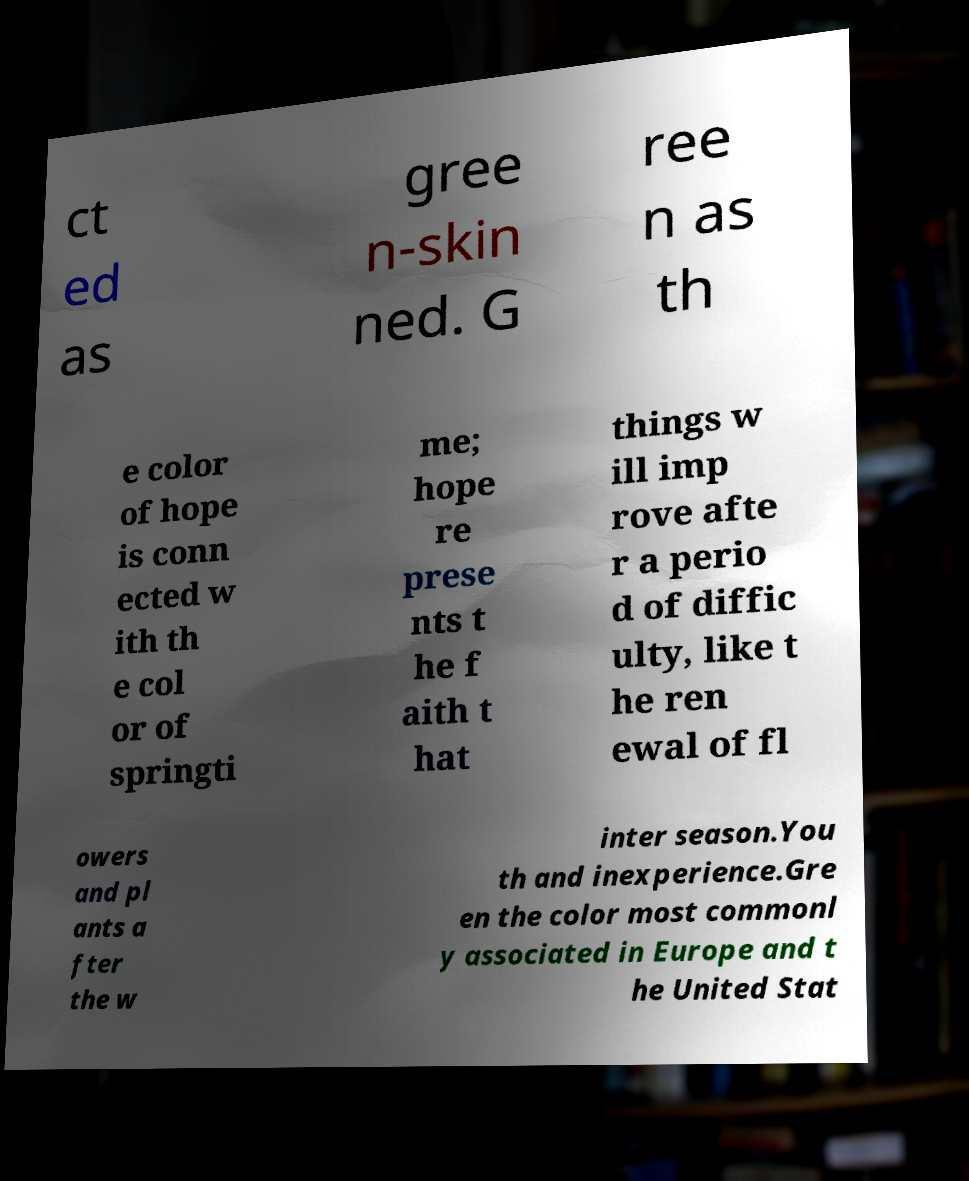For documentation purposes, I need the text within this image transcribed. Could you provide that? ct ed as gree n-skin ned. G ree n as th e color of hope is conn ected w ith th e col or of springti me; hope re prese nts t he f aith t hat things w ill imp rove afte r a perio d of diffic ulty, like t he ren ewal of fl owers and pl ants a fter the w inter season.You th and inexperience.Gre en the color most commonl y associated in Europe and t he United Stat 